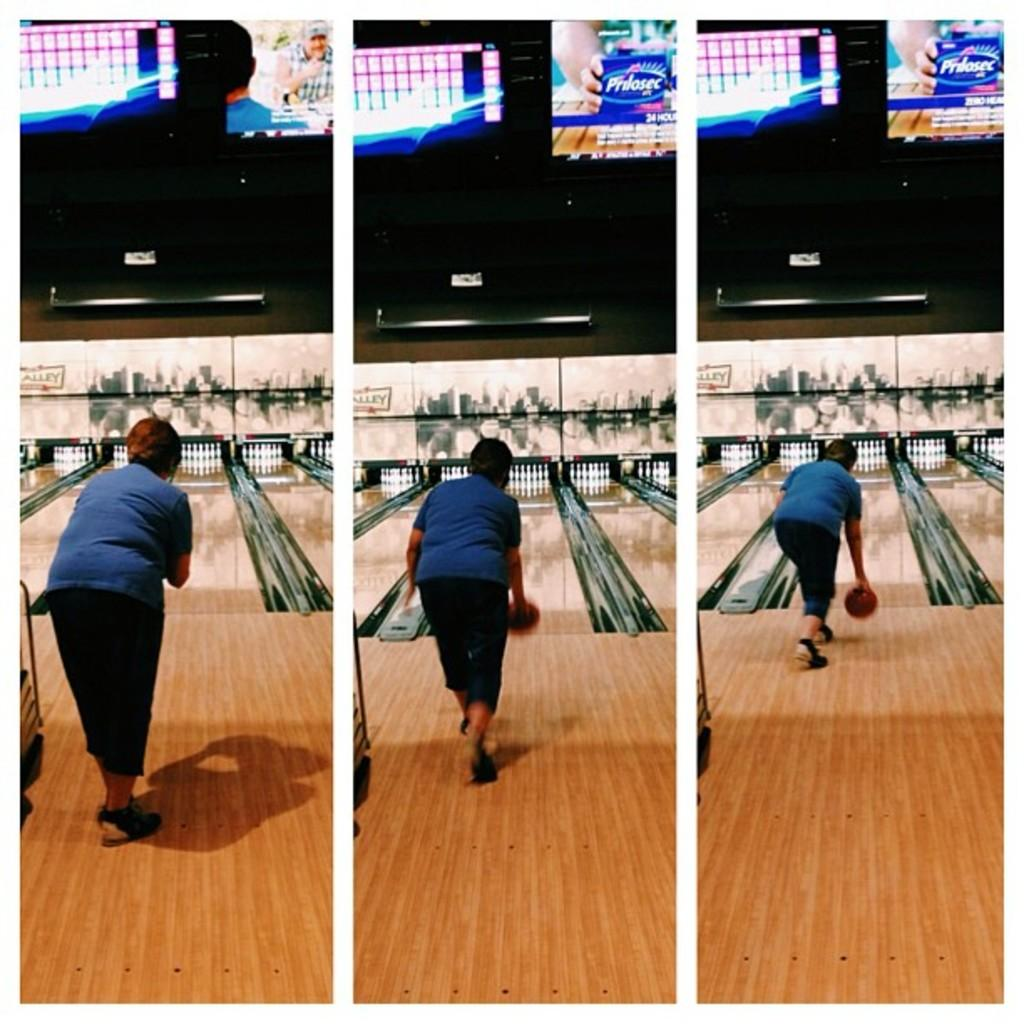What is the main subject of the collage picture at the top of the image? The main subject of the collage picture at the top of the image is a laptop screen. What activity is being depicted in the collage picture at the bottom of the image? The collage picture at the bottom of the image depicts a person doing bowling. What type of yam is being used as a crib in the image? There is no yam or crib present in the image. How many islands can be seen in the image? There are no islands present in the image. 